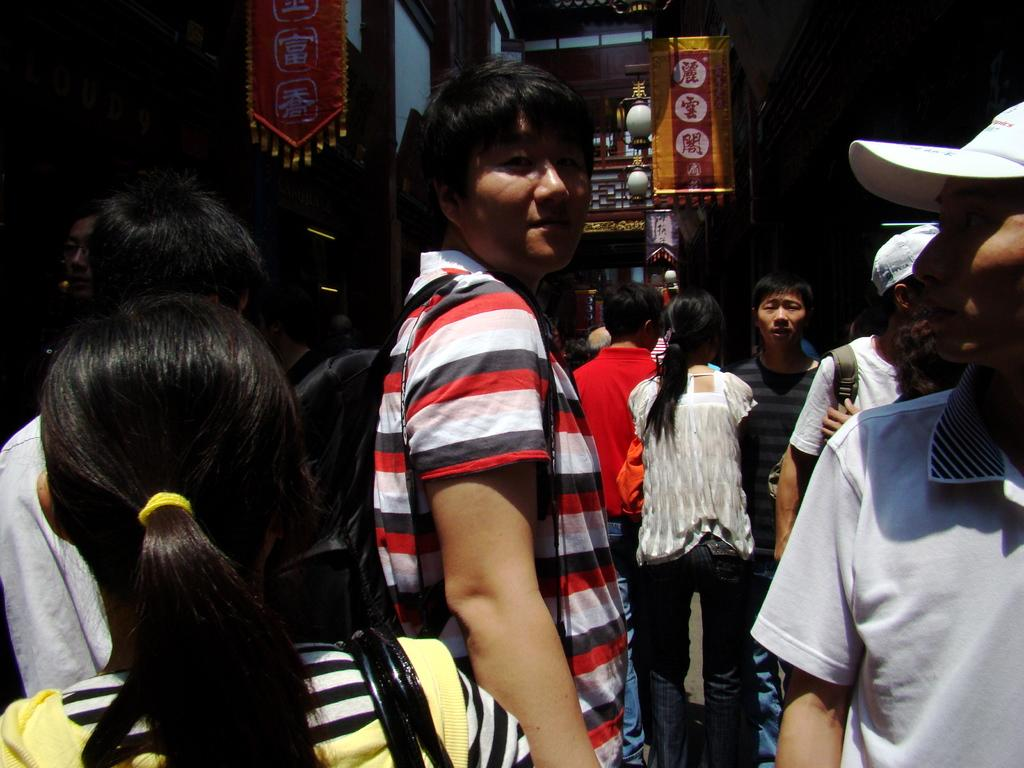How many people are in the image? There is a group of people in the image. What are the people in the image doing? The people are standing. What can be seen in the background of the image? There are hoardings, lights, and buildings in the background of the image. What type of wine is the grandfather drinking in the image? There is no grandfather or wine present in the image. 